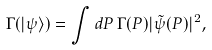<formula> <loc_0><loc_0><loc_500><loc_500>\Gamma ( | \psi \rangle ) = \int d P \, \Gamma ( P ) | \tilde { \psi } ( P ) | ^ { 2 } ,</formula> 